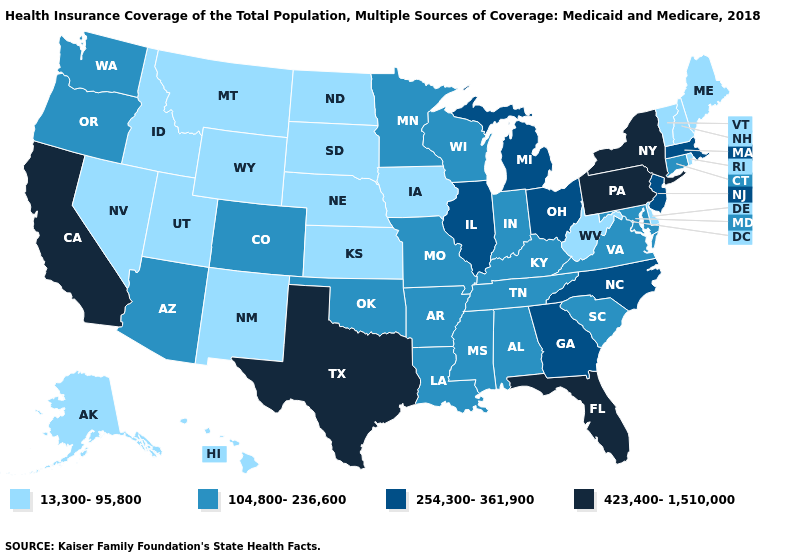What is the value of Alaska?
Give a very brief answer. 13,300-95,800. Name the states that have a value in the range 104,800-236,600?
Keep it brief. Alabama, Arizona, Arkansas, Colorado, Connecticut, Indiana, Kentucky, Louisiana, Maryland, Minnesota, Mississippi, Missouri, Oklahoma, Oregon, South Carolina, Tennessee, Virginia, Washington, Wisconsin. What is the value of Georgia?
Short answer required. 254,300-361,900. Does the first symbol in the legend represent the smallest category?
Concise answer only. Yes. Name the states that have a value in the range 423,400-1,510,000?
Be succinct. California, Florida, New York, Pennsylvania, Texas. What is the lowest value in the West?
Quick response, please. 13,300-95,800. Does West Virginia have the lowest value in the South?
Short answer required. Yes. What is the value of Minnesota?
Give a very brief answer. 104,800-236,600. Name the states that have a value in the range 254,300-361,900?
Short answer required. Georgia, Illinois, Massachusetts, Michigan, New Jersey, North Carolina, Ohio. Does Montana have the highest value in the USA?
Write a very short answer. No. What is the highest value in the USA?
Concise answer only. 423,400-1,510,000. How many symbols are there in the legend?
Write a very short answer. 4. What is the highest value in states that border Mississippi?
Answer briefly. 104,800-236,600. What is the value of Kansas?
Answer briefly. 13,300-95,800. 